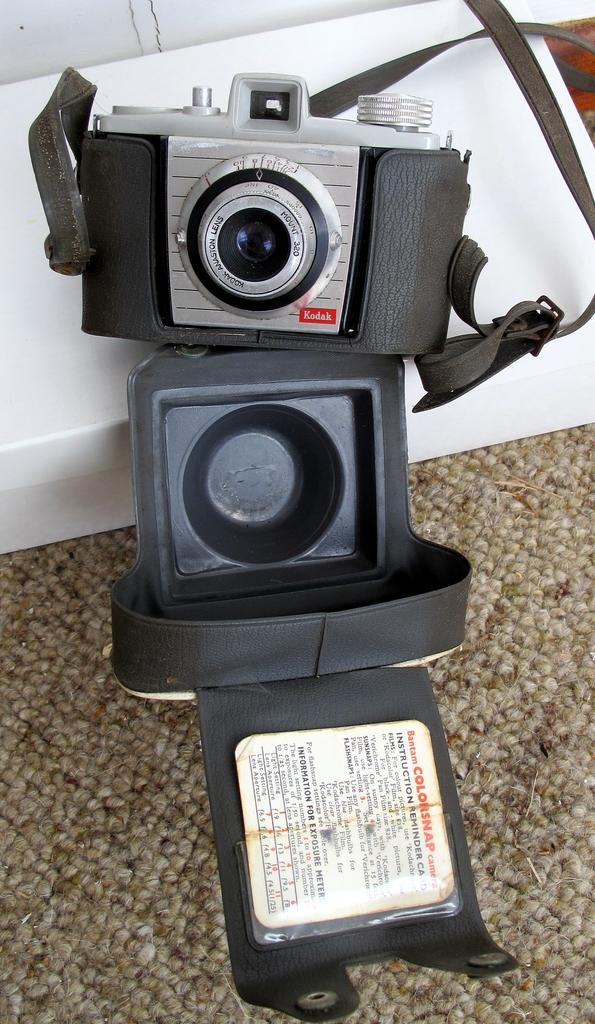What object is the main subject of the image? There is a camera in the image. Where is the camera located in the image? The camera is present over a place. How many children are visible under the quilt in the image? There is no quilt or children present in the image; it features a camera. What expertise does the expert have in the image? There is no expert present in the image; it features a camera. 